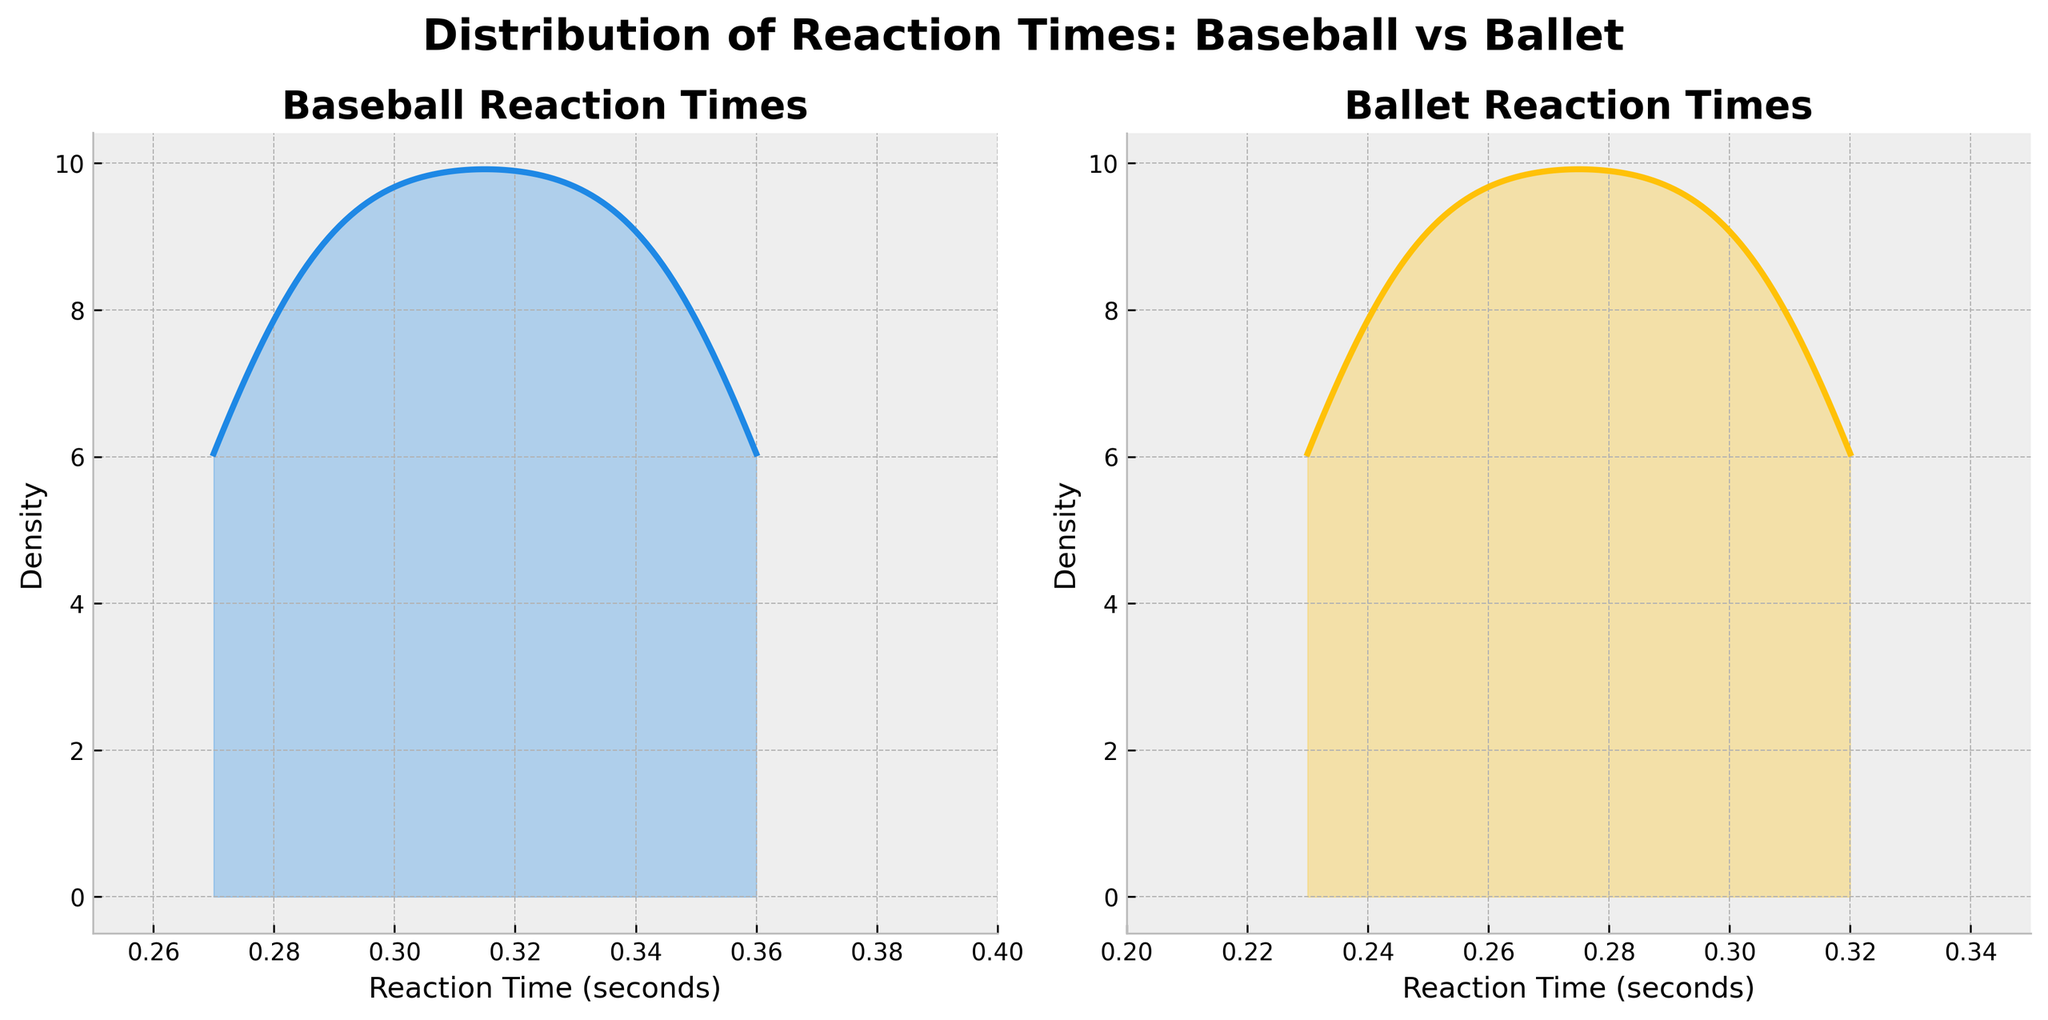What is the title of the figure? The title of the figure is located at the top, displayed prominently in larger and bold font compared to the other text. It reads "Distribution of Reaction Times: Baseball vs Ballet".
Answer: Distribution of Reaction Times: Baseball vs Ballet What color represents the reaction times for baseball? In the density plot, the curve and shaded area representing baseball reaction times are colored in a shade of blue.
Answer: Blue Between which range do the baseball reaction times fall? By observing the x-axis of the subplot for baseball reaction times, it's evident that the values range from 0.25 to 0.4 seconds.
Answer: 0.25 to 0.4 seconds Which movement type appears to have the lowest reaction time for ballet? The subplot for ballet reaction times shows points plotted, indicating different movements. The subplot that includes data contains 10 ballet reaction times, with the lowest ballet reaction time approximating 0.23 seconds, likely associated with "Quick turn and catch".
Answer: Quick turn and catch Are ballet reaction times generally faster or slower compared to baseball reaction times? Comparing the two subplots, we see that the center of the ballet reaction times curve is consistently at lower values on the x-axis (approximately 0.24 to 0.32 seconds) than the baseball curve.
Answer: Faster What is the peak density value for the baseball reaction time density curve? Observing closely, it is clear the peak of the baseball density curve, where it reaches its maximum height, is around 0.28 seconds.
Answer: Approximately 0.28 seconds Which reaction time distribution appears wider? By examining the spread of both density curves in their respective subplots, it's apparent that the baseball reaction times have a wider distribution stretching from 0.25 to 0.4, compared to ballet times.
Answer: Baseball reaction times What is the color used for the ballet reaction time curve? The ballet reaction times curve is displayed in a shade of yellow.
Answer: Yellow What is the axis label for the x-axis in the baseball reaction times subplot? The x-axis for the baseball subplot is labeled "Reaction Time (seconds)". This notation is found just below the x-axis ticks.
Answer: Reaction Time (seconds) What relationship can you infer from comparing the average ballet reaction times to average baseball reaction times? Comparing the central tendency of the density curves, the ballet times are generally quicker than the baseball times, indicated by their positions more to the left on the x-axis. This suggests shorter reaction times on average for ballet.
Answer: Ballet reaction times are on average quicker than baseball reaction times 